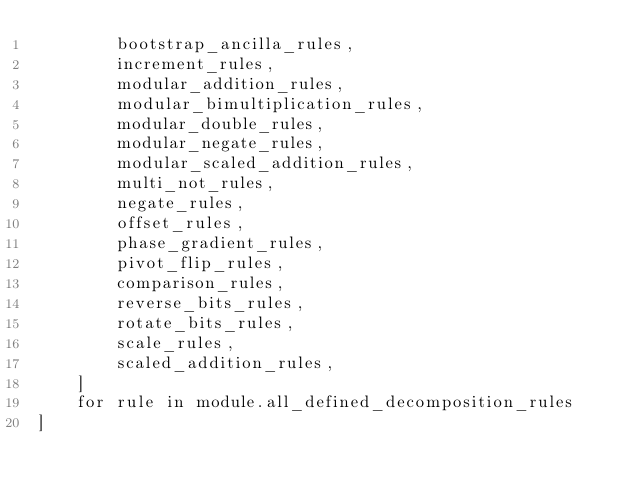Convert code to text. <code><loc_0><loc_0><loc_500><loc_500><_Python_>        bootstrap_ancilla_rules,
        increment_rules,
        modular_addition_rules,
        modular_bimultiplication_rules,
        modular_double_rules,
        modular_negate_rules,
        modular_scaled_addition_rules,
        multi_not_rules,
        negate_rules,
        offset_rules,
        phase_gradient_rules,
        pivot_flip_rules,
        comparison_rules,
        reverse_bits_rules,
        rotate_bits_rules,
        scale_rules,
        scaled_addition_rules,
    ]
    for rule in module.all_defined_decomposition_rules
]
</code> 